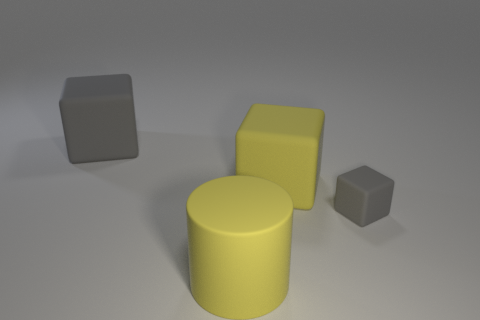Subtract all tiny gray blocks. How many blocks are left? 2 Subtract all green balls. How many gray cubes are left? 2 Add 4 tiny yellow metallic cubes. How many objects exist? 8 Subtract all blocks. How many objects are left? 1 Subtract all green cubes. Subtract all red balls. How many cubes are left? 3 Subtract all small gray balls. Subtract all blocks. How many objects are left? 1 Add 3 small gray rubber objects. How many small gray rubber objects are left? 4 Add 4 tiny cyan metal cylinders. How many tiny cyan metal cylinders exist? 4 Subtract 0 red cylinders. How many objects are left? 4 